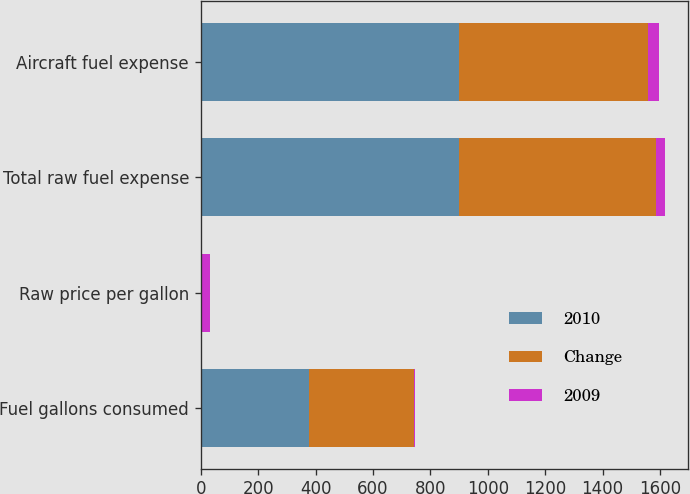Convert chart. <chart><loc_0><loc_0><loc_500><loc_500><stacked_bar_chart><ecel><fcel>Fuel gallons consumed<fcel>Raw price per gallon<fcel>Total raw fuel expense<fcel>Aircraft fuel expense<nl><fcel>2010<fcel>377.3<fcel>2.38<fcel>898.9<fcel>900.9<nl><fcel>Change<fcel>365<fcel>1.88<fcel>686.2<fcel>658.1<nl><fcel>2009<fcel>3.4<fcel>26.6<fcel>31<fcel>36.9<nl></chart> 